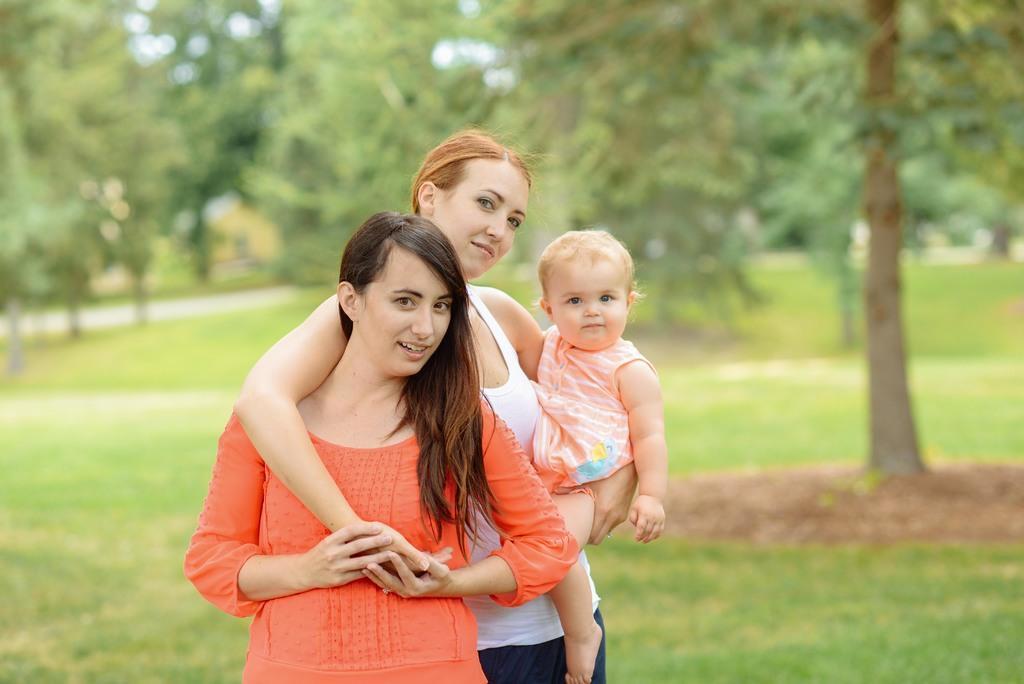Please provide a concise description of this image. In this image we can see this woman wearing orange dress, this woman wearing white T-shirt is carrying a child and are standing on the grass. The background of the image is slightly blurred, where we can see trees. 